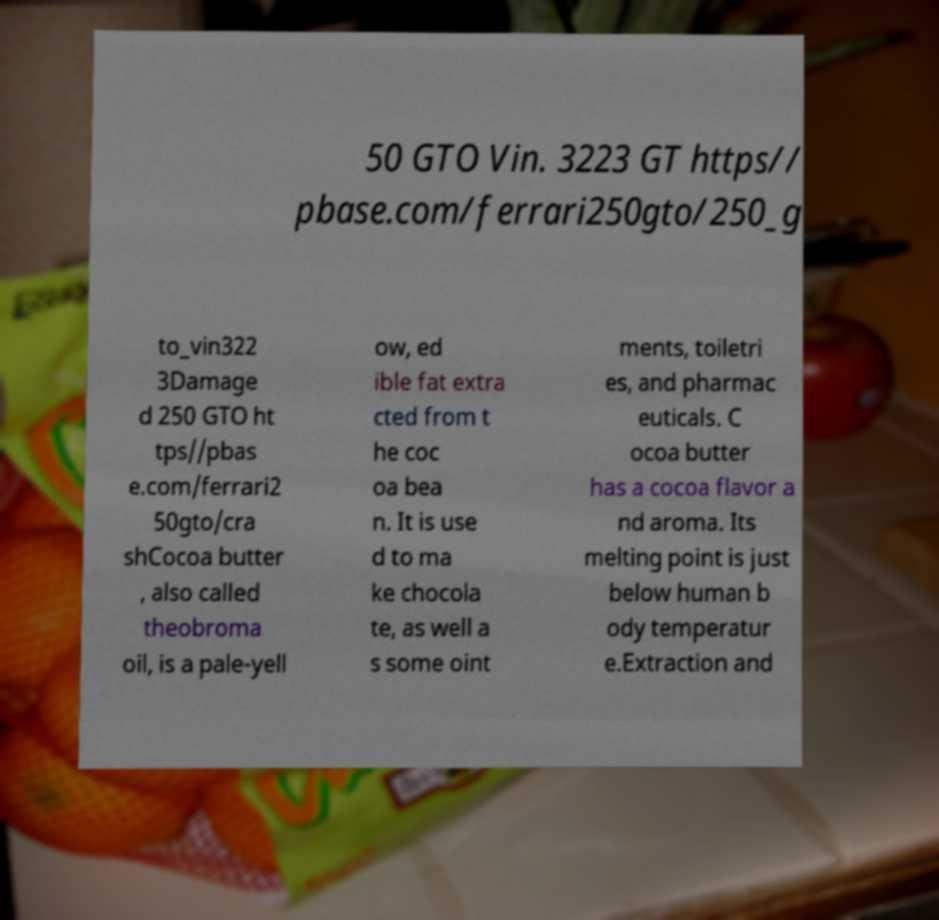I need the written content from this picture converted into text. Can you do that? 50 GTO Vin. 3223 GT https// pbase.com/ferrari250gto/250_g to_vin322 3Damage d 250 GTO ht tps//pbas e.com/ferrari2 50gto/cra shCocoa butter , also called theobroma oil, is a pale-yell ow, ed ible fat extra cted from t he coc oa bea n. It is use d to ma ke chocola te, as well a s some oint ments, toiletri es, and pharmac euticals. C ocoa butter has a cocoa flavor a nd aroma. Its melting point is just below human b ody temperatur e.Extraction and 